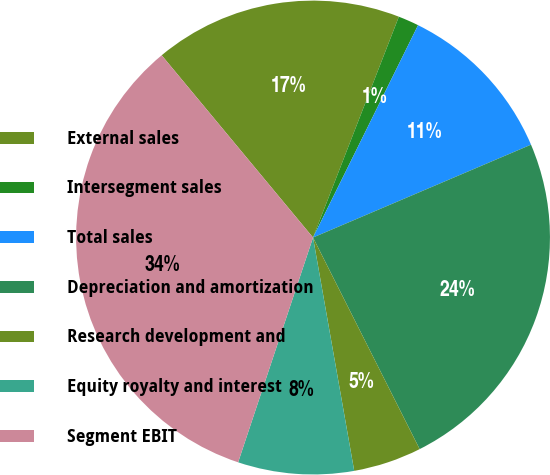Convert chart to OTSL. <chart><loc_0><loc_0><loc_500><loc_500><pie_chart><fcel>External sales<fcel>Intersegment sales<fcel>Total sales<fcel>Depreciation and amortization<fcel>Research development and<fcel>Equity royalty and interest<fcel>Segment EBIT<nl><fcel>16.93%<fcel>1.41%<fcel>11.28%<fcel>23.98%<fcel>4.65%<fcel>7.9%<fcel>33.85%<nl></chart> 